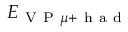<formula> <loc_0><loc_0><loc_500><loc_500>E _ { V P \mu + h a d }</formula> 